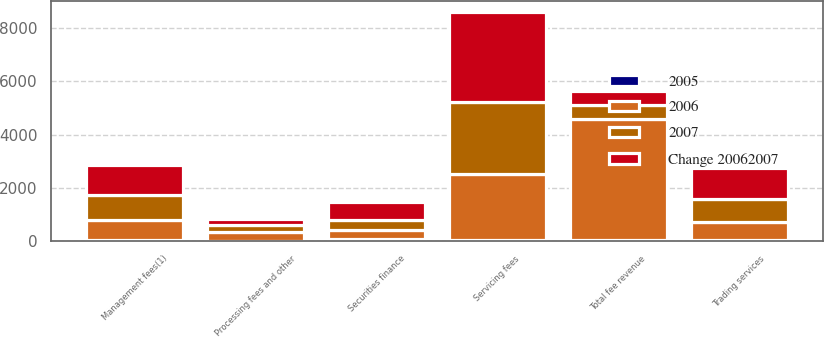Convert chart. <chart><loc_0><loc_0><loc_500><loc_500><stacked_bar_chart><ecel><fcel>Servicing fees<fcel>Management fees(1)<fcel>Trading services<fcel>Securities finance<fcel>Processing fees and other<fcel>Total fee revenue<nl><fcel>Change 20062007<fcel>3388<fcel>1141<fcel>1152<fcel>681<fcel>237<fcel>533.5<nl><fcel>2007<fcel>2723<fcel>943<fcel>862<fcel>386<fcel>272<fcel>533.5<nl><fcel>2006<fcel>2474<fcel>751<fcel>694<fcel>330<fcel>302<fcel>4551<nl><fcel>2005<fcel>24<fcel>21<fcel>34<fcel>76<fcel>13<fcel>27<nl></chart> 